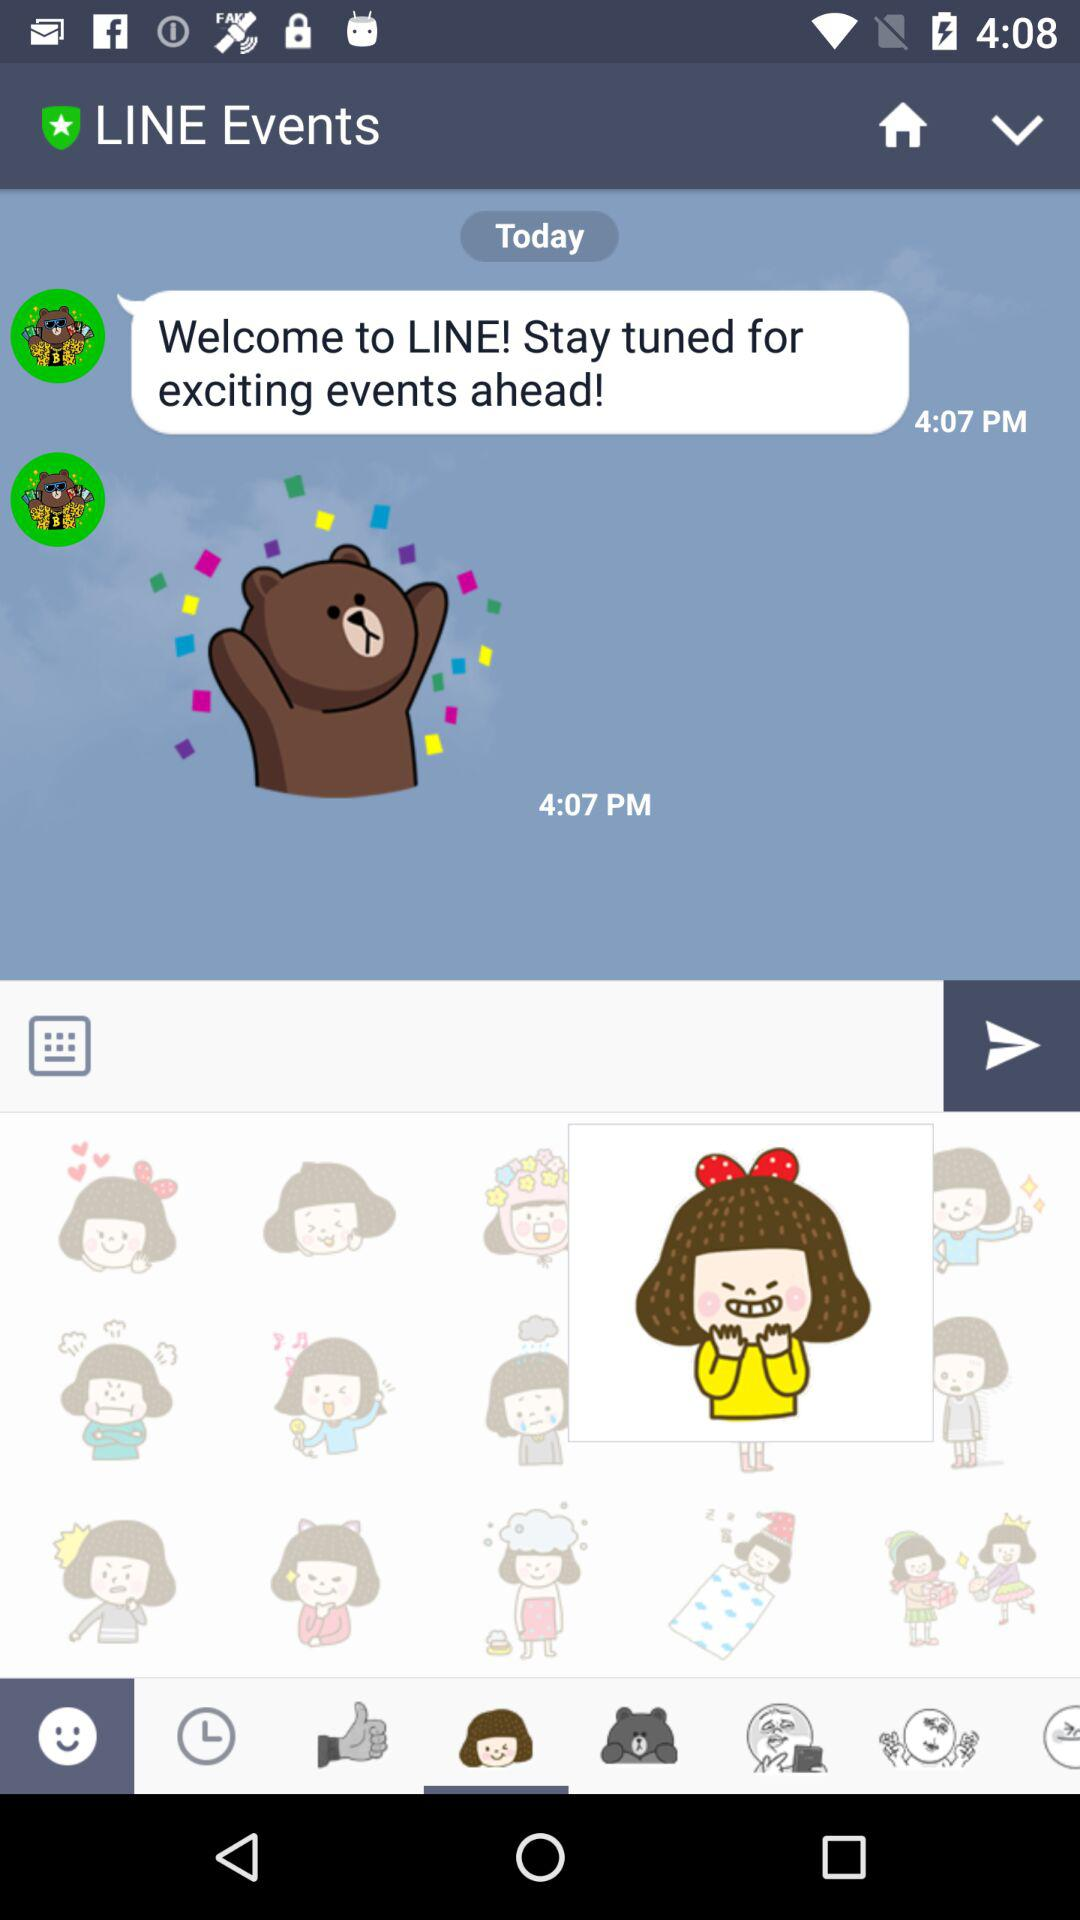What is the time of the last message's arrival? The time is 4:07 PM. 